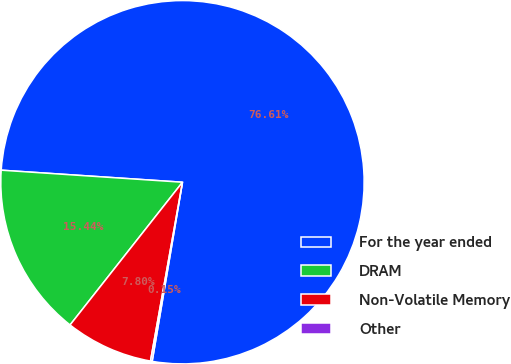Convert chart to OTSL. <chart><loc_0><loc_0><loc_500><loc_500><pie_chart><fcel>For the year ended<fcel>DRAM<fcel>Non-Volatile Memory<fcel>Other<nl><fcel>76.61%<fcel>15.44%<fcel>7.8%<fcel>0.15%<nl></chart> 